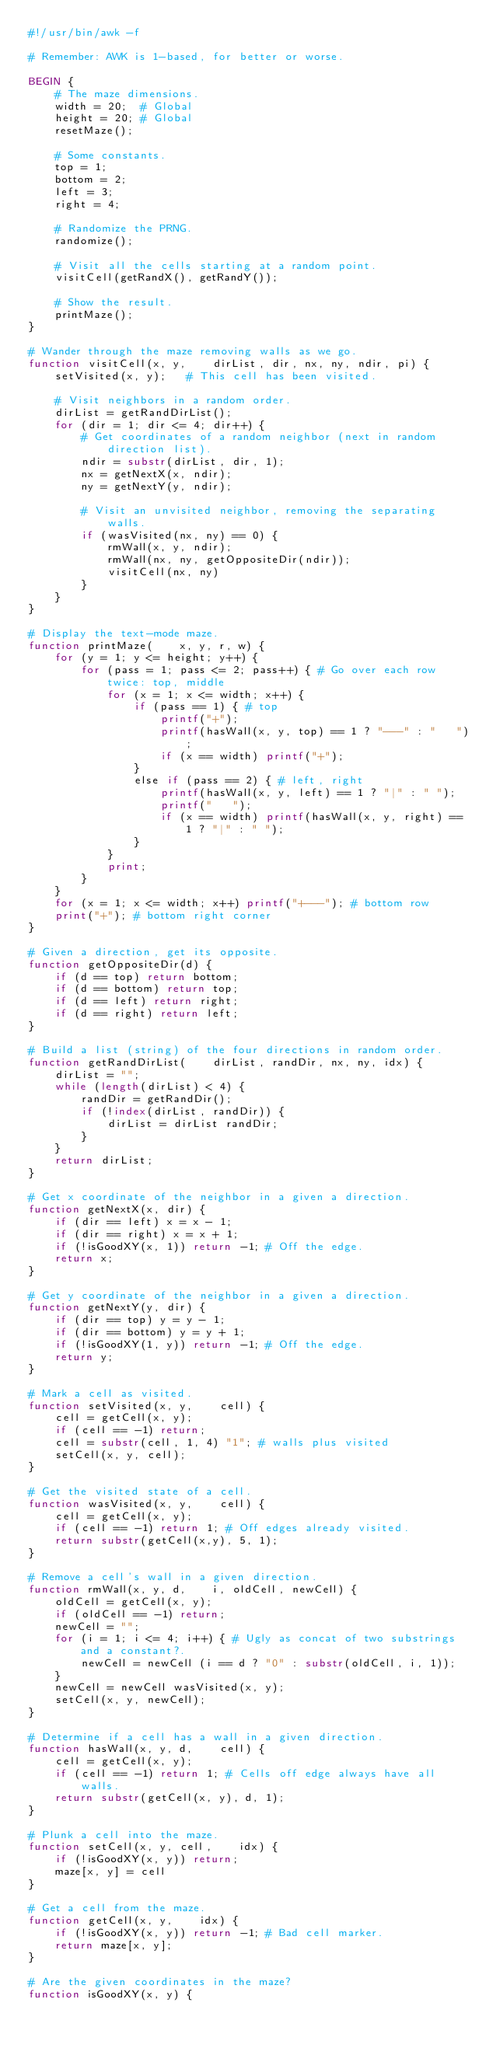<code> <loc_0><loc_0><loc_500><loc_500><_Awk_>#!/usr/bin/awk -f

# Remember: AWK is 1-based, for better or worse.

BEGIN {
    # The maze dimensions.
    width = 20;  # Global
    height = 20; # Global
    resetMaze();

    # Some constants.
    top = 1;
    bottom = 2;
    left = 3;
    right = 4;

    # Randomize the PRNG.
    randomize();

    # Visit all the cells starting at a random point.
    visitCell(getRandX(), getRandY());

    # Show the result.
    printMaze();
}

# Wander through the maze removing walls as we go.
function visitCell(x, y,    dirList, dir, nx, ny, ndir, pi) {
    setVisited(x, y);   # This cell has been visited.

    # Visit neighbors in a random order.
    dirList = getRandDirList();
    for (dir = 1; dir <= 4; dir++) {
        # Get coordinates of a random neighbor (next in random direction list).
        ndir = substr(dirList, dir, 1);
        nx = getNextX(x, ndir);
        ny = getNextY(y, ndir);

        # Visit an unvisited neighbor, removing the separating walls.
        if (wasVisited(nx, ny) == 0) {
            rmWall(x, y, ndir);
            rmWall(nx, ny, getOppositeDir(ndir));
            visitCell(nx, ny)
        }
    }
}

# Display the text-mode maze.
function printMaze(    x, y, r, w) {
    for (y = 1; y <= height; y++) {
        for (pass = 1; pass <= 2; pass++) { # Go over each row twice: top, middle
            for (x = 1; x <= width; x++) {
                if (pass == 1) { # top
                    printf("+");
                    printf(hasWall(x, y, top) == 1 ? "---" : "   ");
                    if (x == width) printf("+");
                }
                else if (pass == 2) { # left, right
                    printf(hasWall(x, y, left) == 1 ? "|" : " ");
                    printf("   ");
                    if (x == width) printf(hasWall(x, y, right) == 1 ? "|" : " ");
                }
            }
            print;
        }
    }
    for (x = 1; x <= width; x++) printf("+---"); # bottom row
    print("+"); # bottom right corner
}

# Given a direction, get its opposite.
function getOppositeDir(d) {
    if (d == top) return bottom;
    if (d == bottom) return top;
    if (d == left) return right;
    if (d == right) return left;
}

# Build a list (string) of the four directions in random order.
function getRandDirList(    dirList, randDir, nx, ny, idx) {
    dirList = "";
    while (length(dirList) < 4) {
        randDir = getRandDir();
        if (!index(dirList, randDir)) {
            dirList = dirList randDir;
        }
    }
    return dirList;
}

# Get x coordinate of the neighbor in a given a direction.
function getNextX(x, dir) {
    if (dir == left) x = x - 1;
    if (dir == right) x = x + 1;
    if (!isGoodXY(x, 1)) return -1; # Off the edge.
    return x;
}

# Get y coordinate of the neighbor in a given a direction.
function getNextY(y, dir) {
    if (dir == top) y = y - 1;
    if (dir == bottom) y = y + 1;
    if (!isGoodXY(1, y)) return -1; # Off the edge.
    return y;
}

# Mark a cell as visited.
function setVisited(x, y,    cell) {
    cell = getCell(x, y);
    if (cell == -1) return;
    cell = substr(cell, 1, 4) "1"; # walls plus visited
    setCell(x, y, cell);
}

# Get the visited state of a cell.
function wasVisited(x, y,    cell) {
    cell = getCell(x, y);
    if (cell == -1) return 1; # Off edges already visited.
    return substr(getCell(x,y), 5, 1);
}

# Remove a cell's wall in a given direction.
function rmWall(x, y, d,    i, oldCell, newCell) {
    oldCell = getCell(x, y);
    if (oldCell == -1) return;
    newCell = "";
    for (i = 1; i <= 4; i++) { # Ugly as concat of two substrings and a constant?.
        newCell = newCell (i == d ? "0" : substr(oldCell, i, 1));
    }
    newCell = newCell wasVisited(x, y);
    setCell(x, y, newCell);
}

# Determine if a cell has a wall in a given direction.
function hasWall(x, y, d,    cell) {
    cell = getCell(x, y);
    if (cell == -1) return 1; # Cells off edge always have all walls.
    return substr(getCell(x, y), d, 1);
}

# Plunk a cell into the maze.
function setCell(x, y, cell,    idx) {
    if (!isGoodXY(x, y)) return;
    maze[x, y] = cell
}

# Get a cell from the maze.
function getCell(x, y,    idx) {
    if (!isGoodXY(x, y)) return -1; # Bad cell marker.
    return maze[x, y];
}

# Are the given coordinates in the maze?
function isGoodXY(x, y) {</code> 